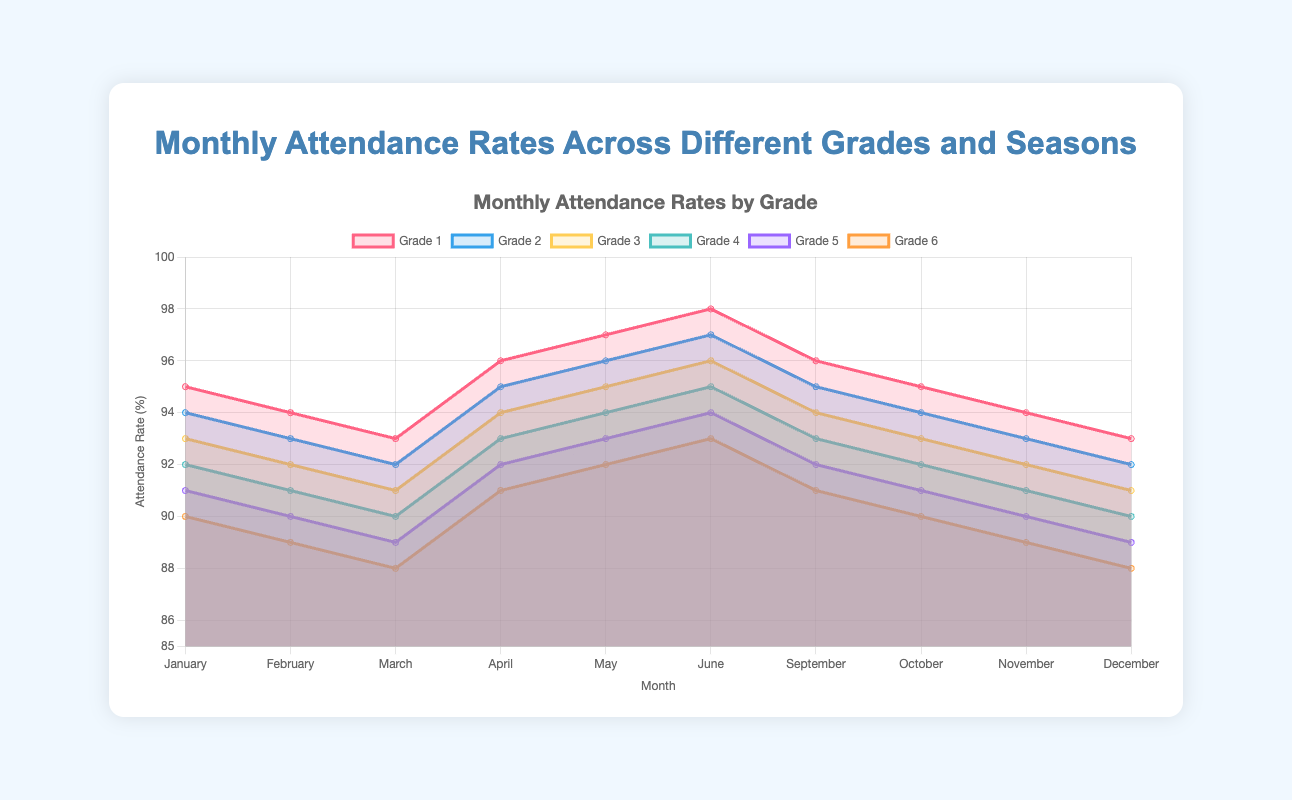What is the title of the chart? The title is displayed prominently at the top of the chart. It gives an overview of what the chart is about.
Answer: "Monthly Attendance Rates Across Different Grades and Seasons" Which grade shows the highest attendance rate in June? Look at the data points for June and compare the attendance rates for each grade.
Answer: Grade 1 What is the overall trend of Grade 6’s attendance from January to December? Notice the direction in which Grade 6's attendance rate changes month by month from January to December.
Answer: Decreasing During which months does Grade 1 show an upward trend in attendance? Observe the data points for Grade 1 and identify the months where the attendance rate increases compared to the previous month.
Answer: April, May, June How does Grade 4’s attendance rate in March compare to its rate in June? Look at the specific values for Grade 4 in both March and June to compare the two.
Answer: The attendance rate in June is higher Which grade or grades have an attendance rate lower than 90% in any given month? Identify months where the attendance rate for any grade falls below 90%.
Answer: Grade 6 What is the average attendance rate for Grade 2 over the entire year? Sum the attendance rates for Grade 2 for each month and divide by the number of months to find the average.
Answer: (94 + 93 + 92 + 95 + 96 + 97 + 95 + 94 + 93 + 92) / 10 = 94.1 In which month does the attendance rate spike the most for Grade 1? Compare the differences in attendance rates month-to-month for Grade 1 to find the largest increase.
Answer: June Which grade has the most consistent attendance rate across the year? Look for the grade with the least fluctuation in attendance rates throughout the months.
Answer: Grade 1 